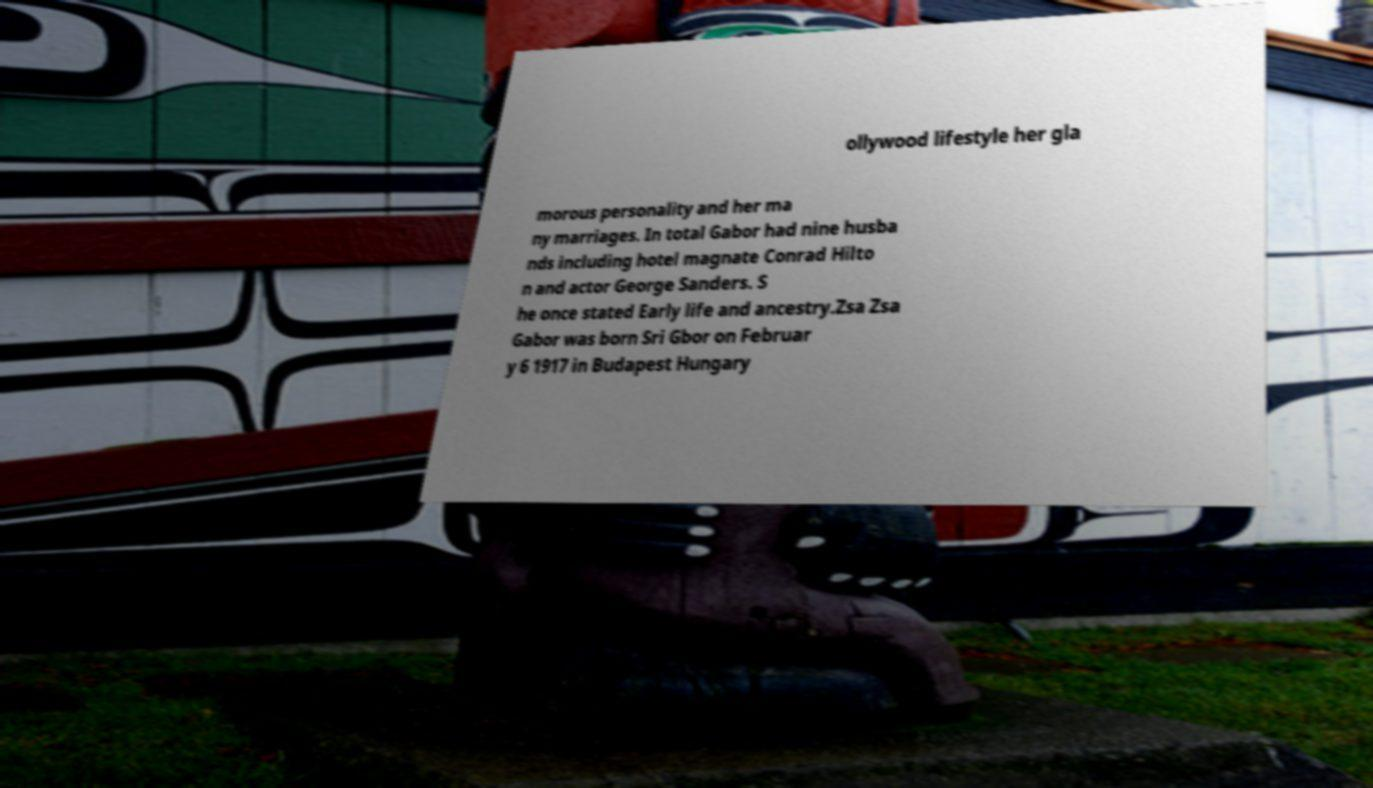Can you read and provide the text displayed in the image?This photo seems to have some interesting text. Can you extract and type it out for me? ollywood lifestyle her gla morous personality and her ma ny marriages. In total Gabor had nine husba nds including hotel magnate Conrad Hilto n and actor George Sanders. S he once stated Early life and ancestry.Zsa Zsa Gabor was born Sri Gbor on Februar y 6 1917 in Budapest Hungary 